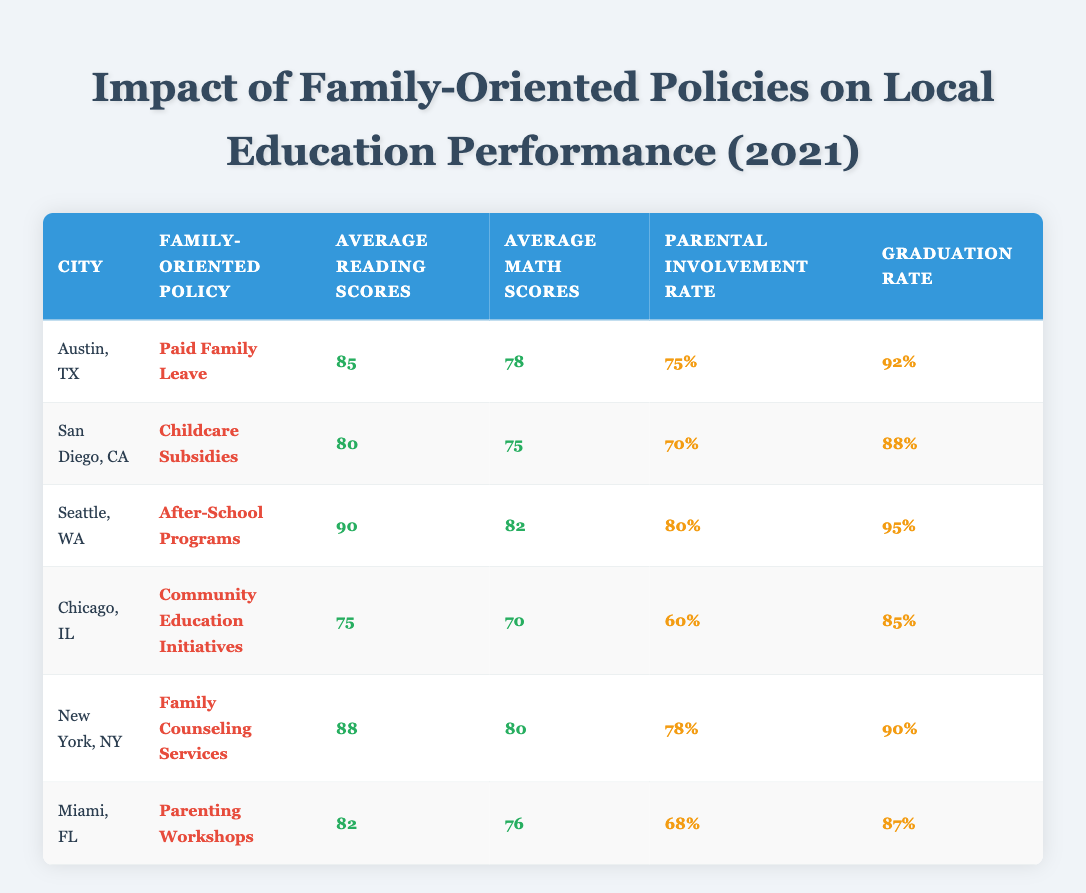What is the average reading score across all cities listed? To calculate the average reading score, sum the individual reading scores: (85 + 80 + 90 + 75 + 88 + 82) = 510. There are 6 cities, so the average is 510/6 = 85.
Answer: 85 Which city has the highest graduation rate? Looking at the graduation rates, Seattle has the highest rate of 95%.
Answer: Seattle, WA Is the average math score for Austin higher than that for Chicago? Austin's average math score is 78, while Chicago's is 70. Since 78 is greater than 70, the statement is true.
Answer: Yes What is the difference in parental involvement rate between Miami and New York? Miami has a parental involvement rate of 68% and New York has 78%. To find the difference, subtract Miami's rate from New York's: 78% - 68% = 10%.
Answer: 10% Do all cities have parental involvement rates above 60%? The lowest parental involvement rate is in Chicago at 60%, which is not above 60%. Thus, not all cities exceed this threshold.
Answer: No Which family-oriented policy corresponds to the highest average reading scores? The policy associated with the highest reading score is "After-School Programs" in Seattle, which has an average score of 90.
Answer: After-School Programs If we consider parental involvement rates, which city shows the largest gap between scores and graduation rates? Analyzing the gaps, Chicago has a parental involvement rate of 60% and a graduation rate of 85%, which provides a gap of 25%. This is larger compared to the other cities.
Answer: Chicago, IL What is the average math score for cities with family counseling services? Only New York offers family counseling services with an average math score of 80. Therefore, the average is simply 80.
Answer: 80 How many cities have both average reading and math scores above 80? The cities with both scores above 80 are Seattle and New York. Thus, there are 2 such cities.
Answer: 2 